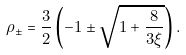<formula> <loc_0><loc_0><loc_500><loc_500>\rho _ { \pm } = \frac { 3 } { 2 } \left ( - 1 \pm \sqrt { 1 + \frac { 8 } { 3 \xi } } \right ) .</formula> 